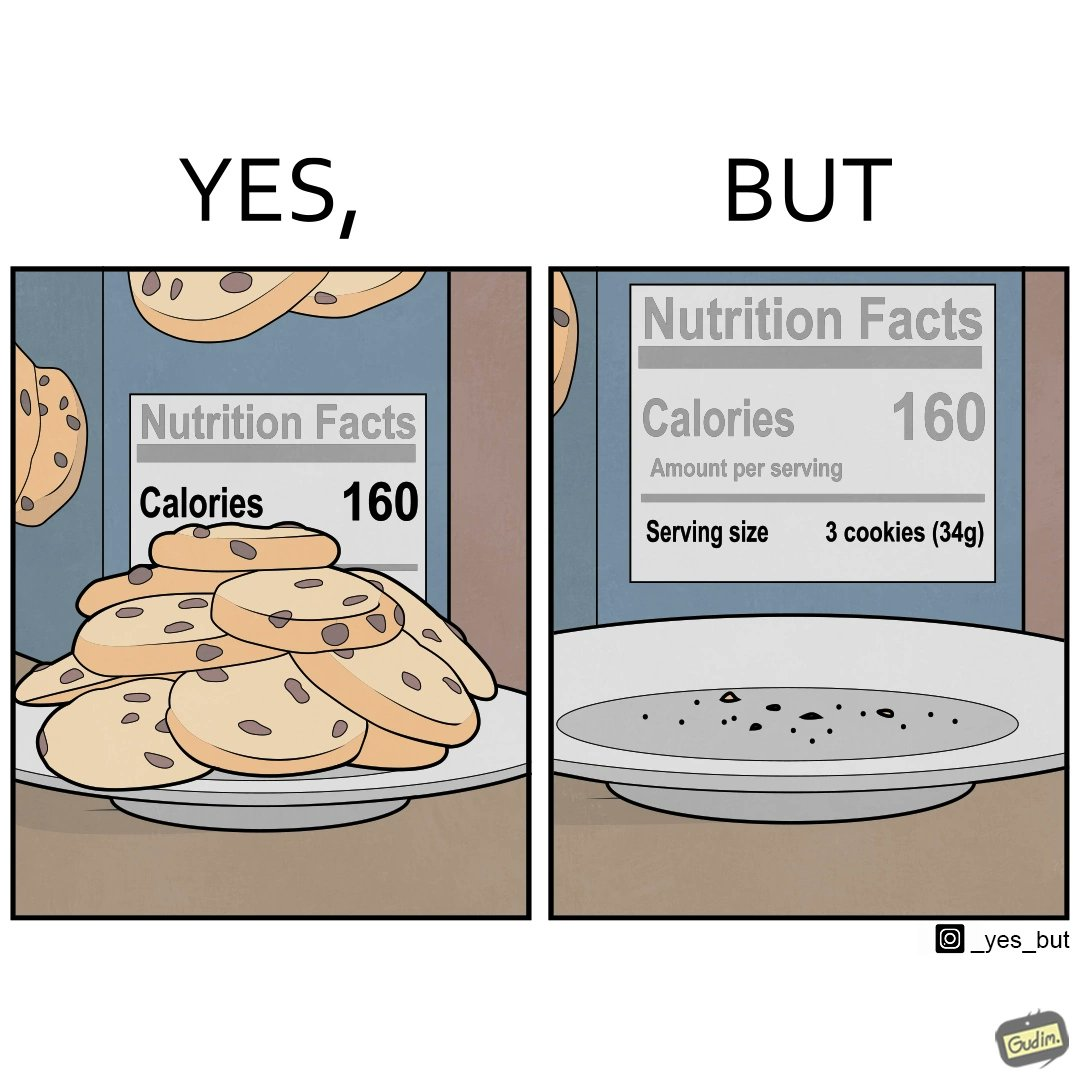Compare the left and right sides of this image. In the left part of the image: The image shows a plate full of cookies. There is also a cookie box behind the plate. The cookie box behind the plate states number of calories as 160 in the nutrition facts table. In the right part of the image: The image on the right shows an empty plate with the cookie box behind it. The cookie box behind the plate states number of calories as 160 for each serving in the nutrition facts table. It is also mentioned that a serving size is 3 cookies which comes out to be 34 grams. 